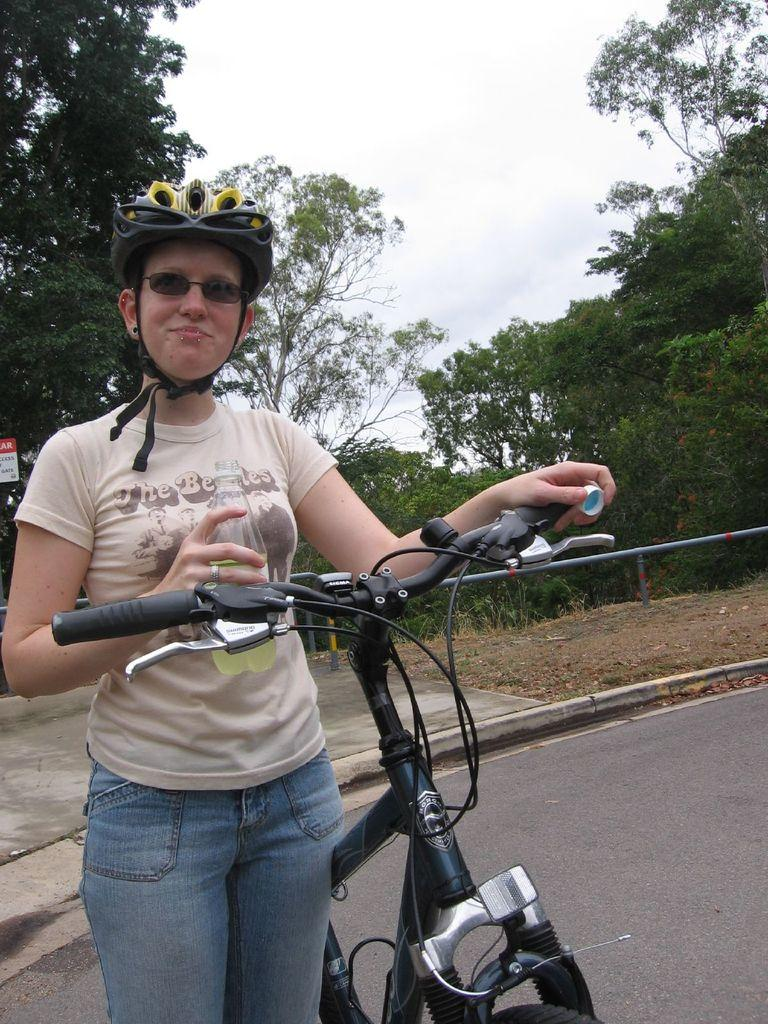Who is the main subject in the image? There is a lady in the image. What is the lady doing in the image? The lady is standing on the road and holding a bicycle. What else is the lady holding in her hand? The lady is holding a bottle in her hand. What can be seen in the background of the image? There are trees and the sky visible in the background of the image. What type of cracker is the lady eating in the image? There is no cracker present in the image; the lady is holding a bicycle and a bottle. Is the lady a queen in the image? There is no indication in the image that the lady is a queen. 